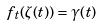Convert formula to latex. <formula><loc_0><loc_0><loc_500><loc_500>f _ { t } ( \zeta ( t ) ) = \gamma ( t )</formula> 